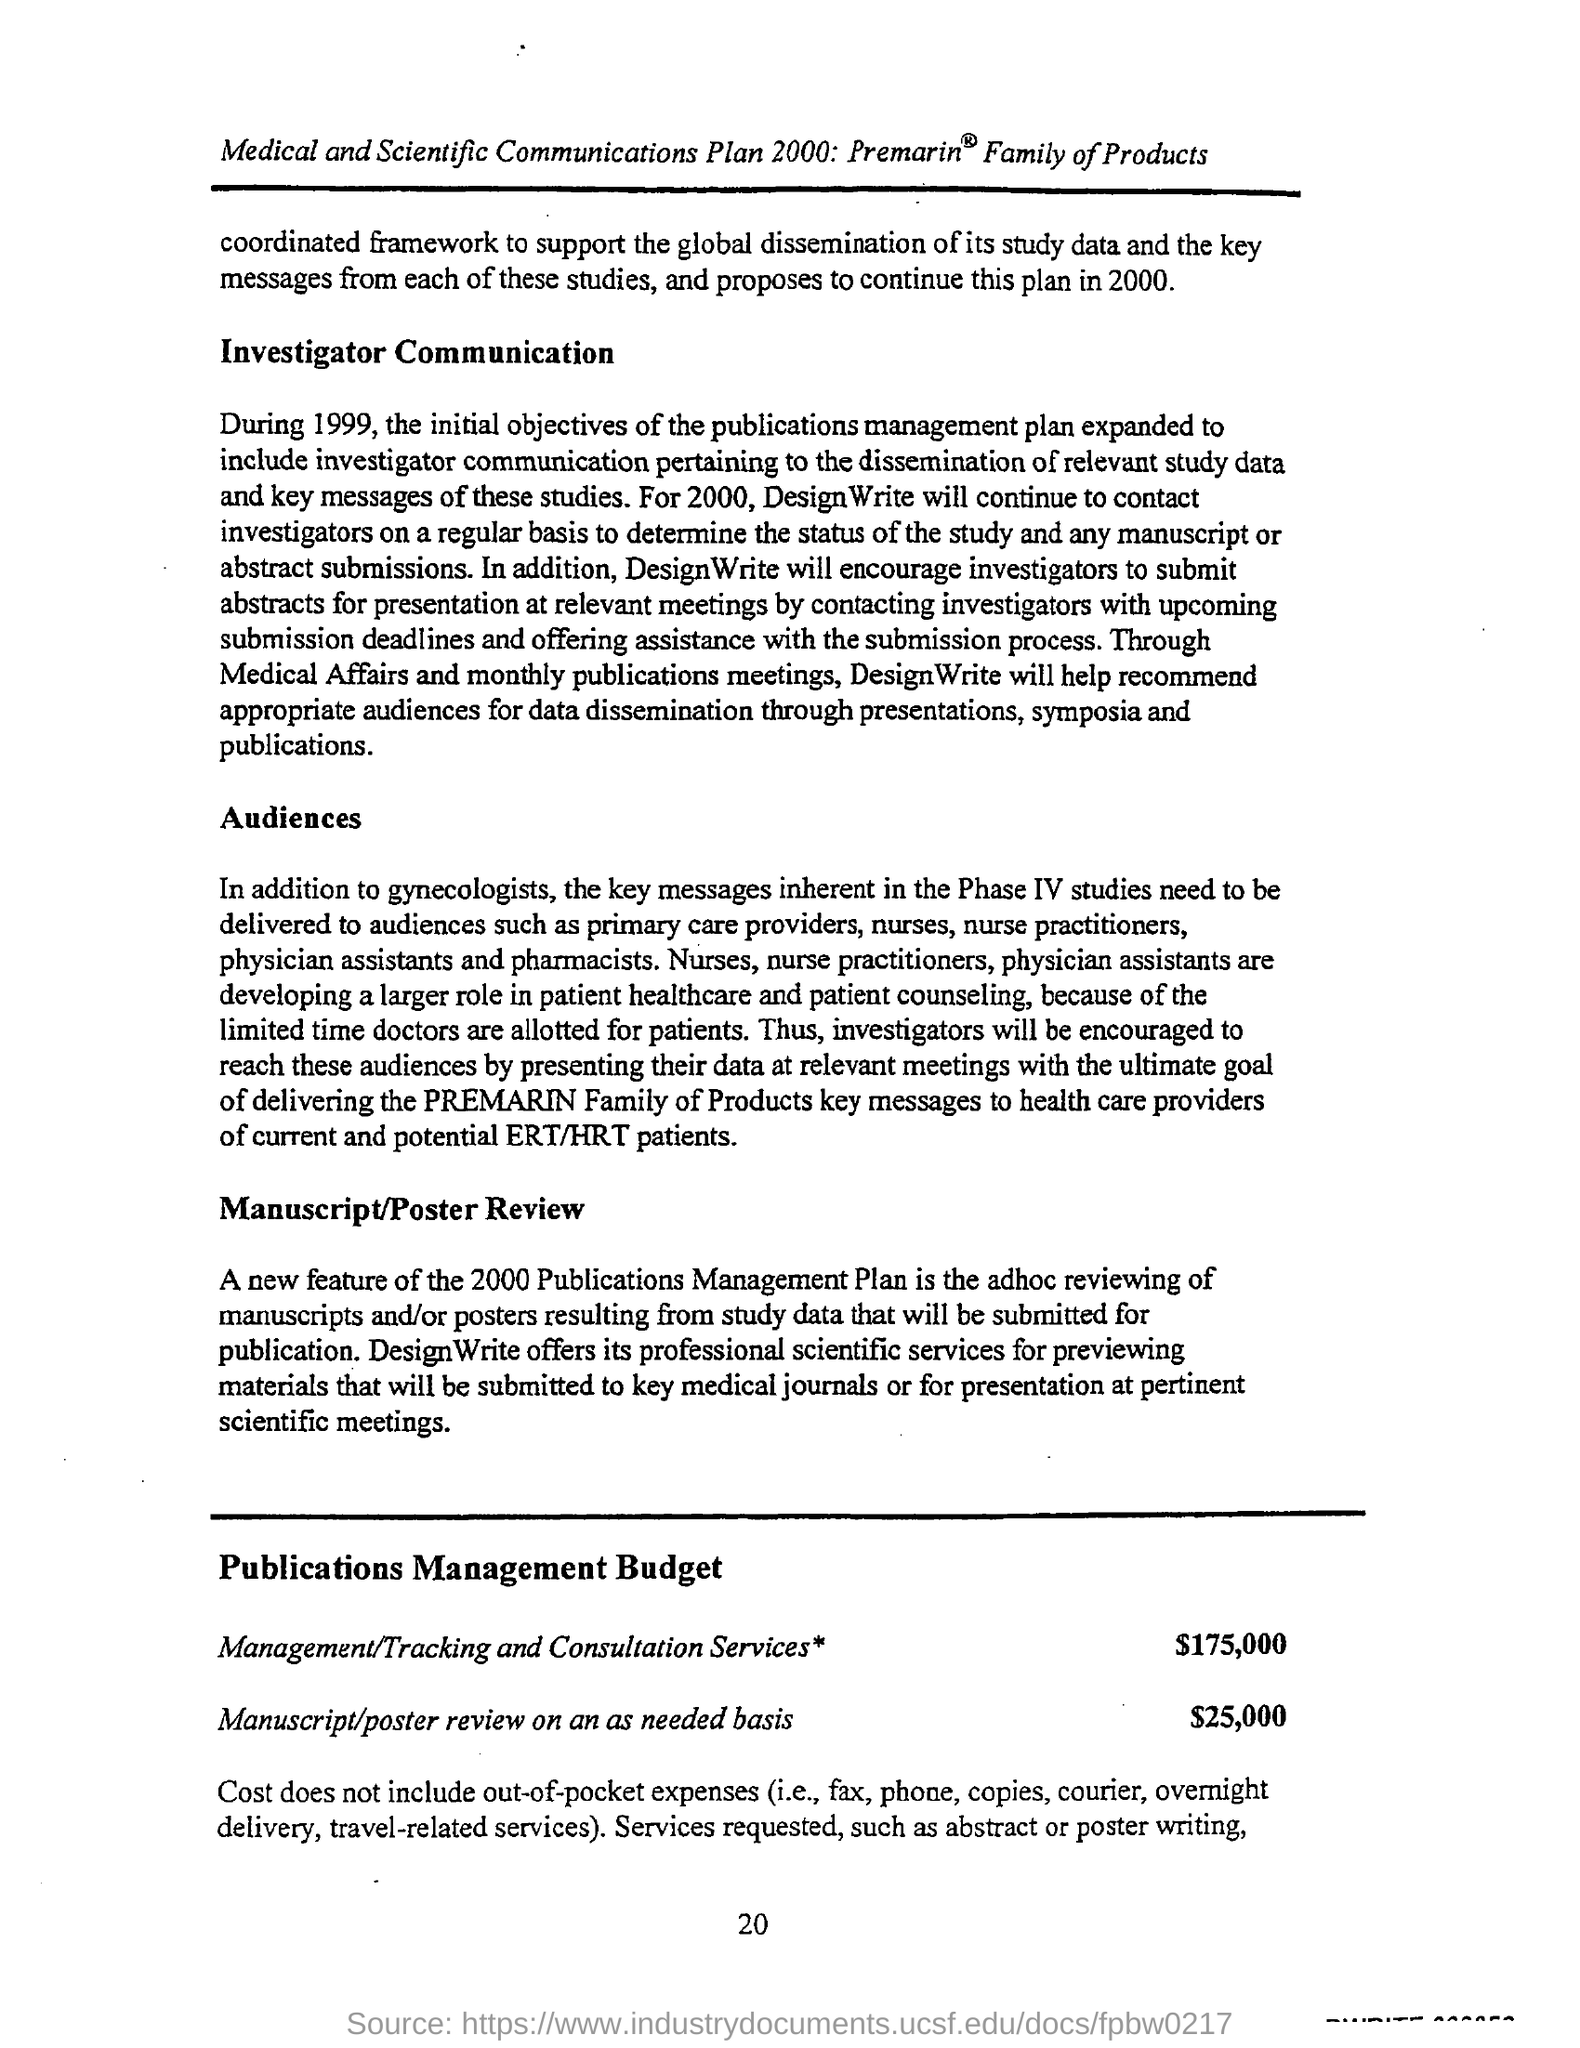Point out several critical features in this image. The budget estimate for manuscript/poster review on an as-needed basis is $25,000. The page number mentioned in this document is 20.. The budget estimate for management/tracking and consultation services is $175,000. 